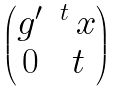Convert formula to latex. <formula><loc_0><loc_0><loc_500><loc_500>\begin{pmatrix} g ^ { \prime } & ^ { t } \, x \\ 0 & t \\ \end{pmatrix}</formula> 